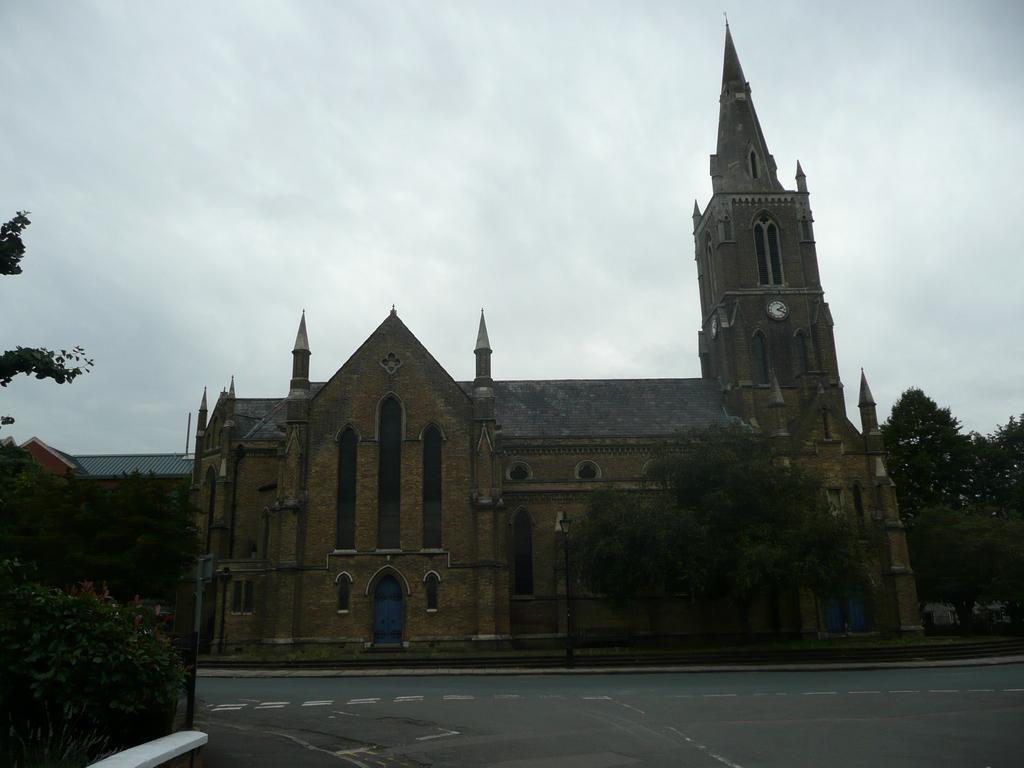Describe this image in one or two sentences. In the center of the image, we can see a building and in the background, there are trees and at the bottom, there is road. At the top, there is sky. 